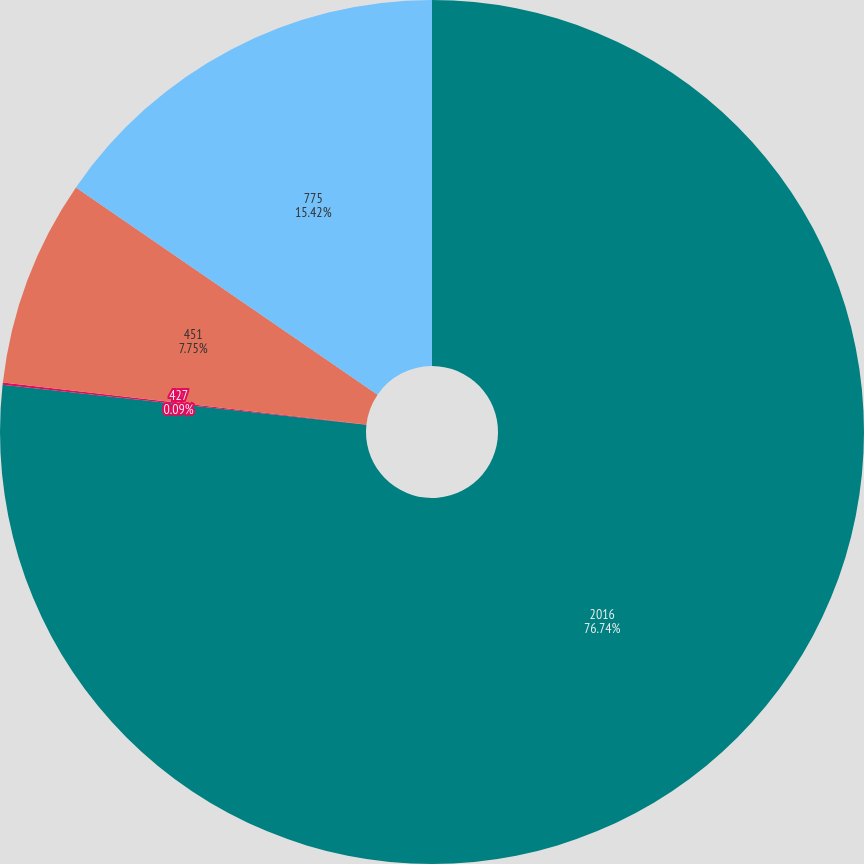Convert chart. <chart><loc_0><loc_0><loc_500><loc_500><pie_chart><fcel>2016<fcel>427<fcel>451<fcel>775<nl><fcel>76.74%<fcel>0.09%<fcel>7.75%<fcel>15.42%<nl></chart> 